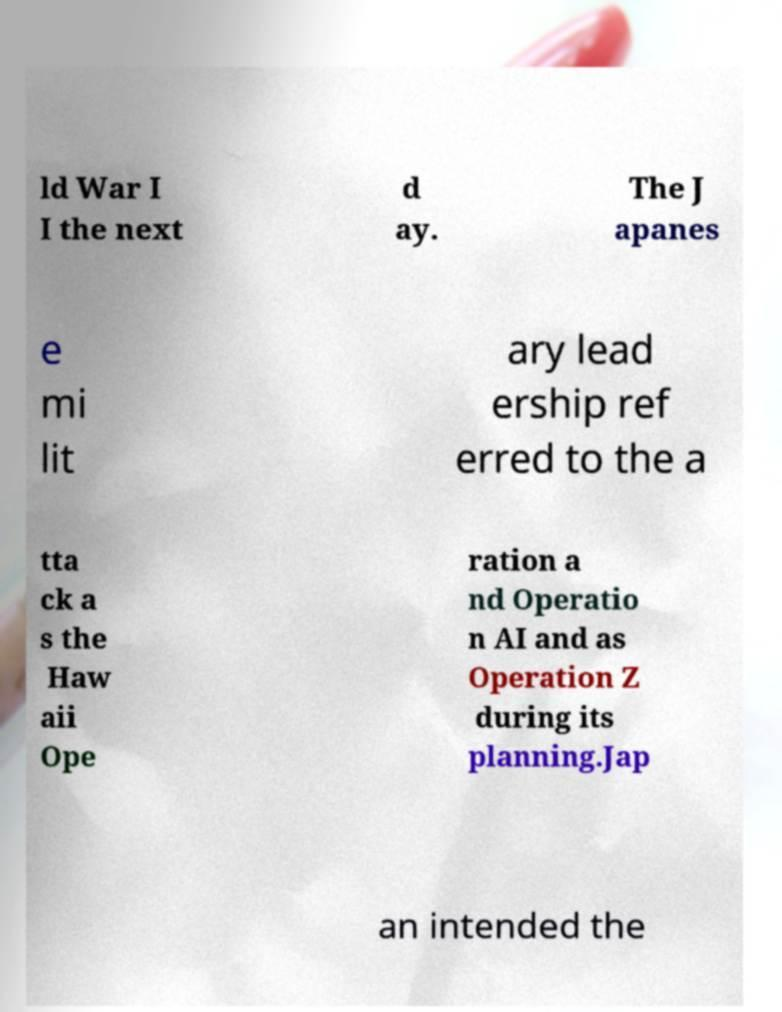Could you extract and type out the text from this image? ld War I I the next d ay. The J apanes e mi lit ary lead ership ref erred to the a tta ck a s the Haw aii Ope ration a nd Operatio n AI and as Operation Z during its planning.Jap an intended the 